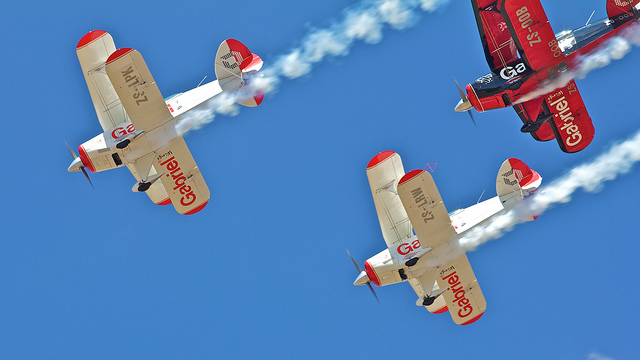Are these modern airplanes? Given their design, which features biplane structures and a vintage aesthetic, these are not modern airplanes but appear to be styled after classic models commonly seen in airshows commemorating aviation history. 